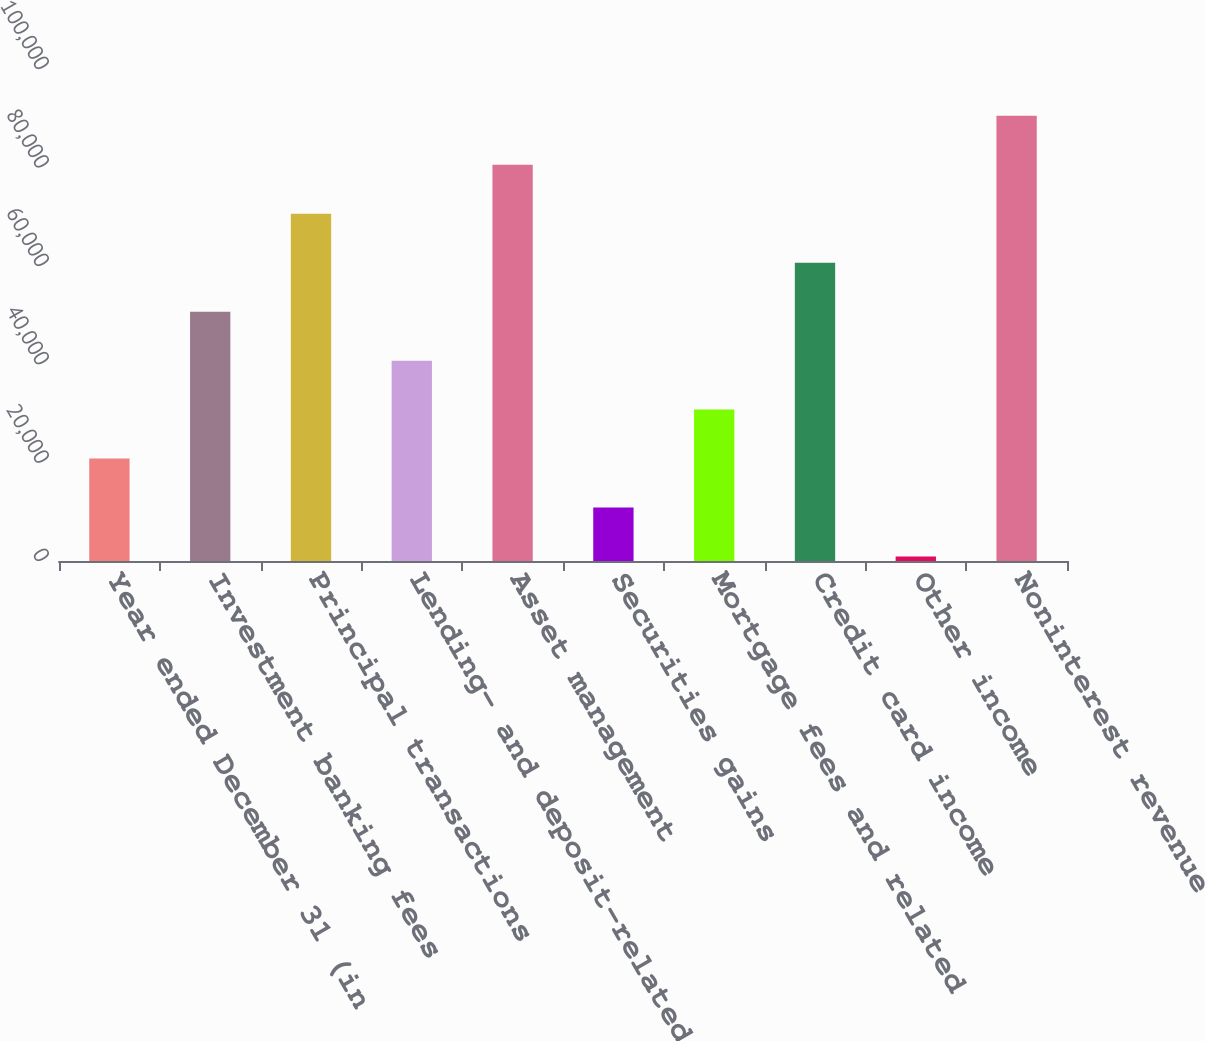<chart> <loc_0><loc_0><loc_500><loc_500><bar_chart><fcel>Year ended December 31 (in<fcel>Investment banking fees<fcel>Principal transactions<fcel>Lending- and deposit-related<fcel>Asset management<fcel>Securities gains<fcel>Mortgage fees and related<fcel>Credit card income<fcel>Other income<fcel>Noninterest revenue<nl><fcel>20819.6<fcel>50675<fcel>70578.6<fcel>40723.2<fcel>80530.4<fcel>10867.8<fcel>30771.4<fcel>60626.8<fcel>916<fcel>90482.2<nl></chart> 